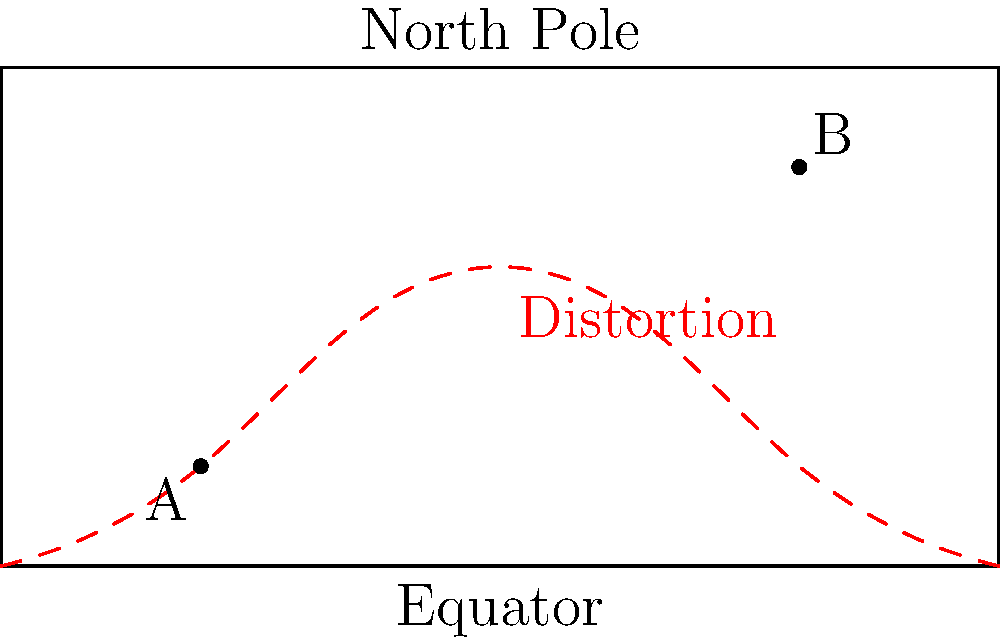In a global military operation, two points A and B are marked on a Mercator projection map as shown. If the straight-line distance between these points on the map is measured as 6000 km, what is the approximate true great circle distance between these points on the Earth's surface, assuming the Earth is a perfect sphere with a radius of 6371 km? To solve this problem, we need to consider the distortion caused by the Mercator projection and calculate the true distance using spherical geometry. Let's break it down step-by-step:

1) The Mercator projection distorts distances, especially near the poles. The straight-line distance on the map doesn't represent the true distance on the Earth's surface.

2) We need to determine the coordinates of points A and B on the sphere. From the map:
   A appears to be at approximately (20°N, 20°E)
   B appears to be at approximately (80°N, 80°E)

3) To calculate the great circle distance, we use the haversine formula:

   $$d = 2R \arcsin(\sqrt{\sin^2(\frac{\Delta\phi}{2}) + \cos\phi_1 \cos\phi_2 \sin^2(\frac{\Delta\lambda}{2})})$$

   Where:
   $R$ is the Earth's radius (6371 km)
   $\phi_1, \phi_2$ are the latitudes of points A and B in radians
   $\Delta\phi$ is the difference in latitudes
   $\Delta\lambda$ is the difference in longitudes

4) Converting to radians:
   $\phi_1 = 20° \times \frac{\pi}{180} = 0.349$ rad
   $\phi_2 = 80° \times \frac{\pi}{180} = 1.396$ rad
   $\Delta\phi = 1.047$ rad
   $\Delta\lambda = 60° \times \frac{\pi}{180} = 1.047$ rad

5) Plugging into the formula:

   $$d = 2 \times 6371 \times \arcsin(\sqrt{\sin^2(\frac{1.047}{2}) + \cos(0.349) \cos(1.396) \sin^2(\frac{1.047}{2})})$$

6) Calculating this gives us approximately 8132 km.

The true great circle distance is significantly larger than the straight-line distance on the Mercator projection map due to the map's distortion, especially at higher latitudes.
Answer: 8132 km 